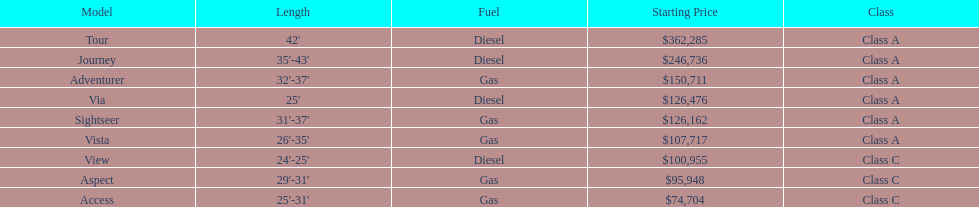What is the amount for both the via and tour models combined? $488,761. 